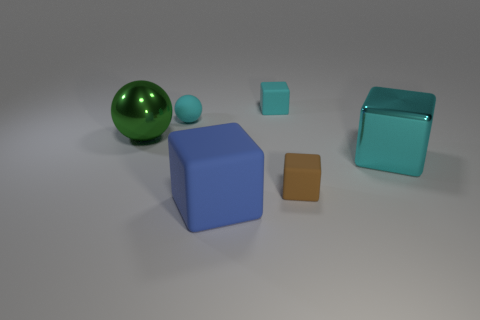Is the number of big metallic spheres behind the large green metal ball greater than the number of small blocks?
Your response must be concise. No. There is a big object that is on the right side of the green shiny thing and left of the brown object; what is it made of?
Ensure brevity in your answer.  Rubber. Is the color of the sphere behind the big green ball the same as the object that is in front of the brown thing?
Your answer should be compact. No. What number of other things are there of the same size as the brown cube?
Keep it short and to the point. 2. There is a tiny rubber sphere in front of the block that is behind the cyan matte sphere; is there a metal sphere behind it?
Offer a terse response. No. Are the big thing that is left of the big blue block and the tiny cyan ball made of the same material?
Keep it short and to the point. No. There is another metal object that is the same shape as the blue thing; what color is it?
Keep it short and to the point. Cyan. Are there any other things that are the same shape as the green object?
Offer a very short reply. Yes. Are there the same number of cubes to the left of the big metallic ball and small brown blocks?
Your answer should be very brief. No. Are there any large green things to the right of the tiny brown matte thing?
Keep it short and to the point. No. 